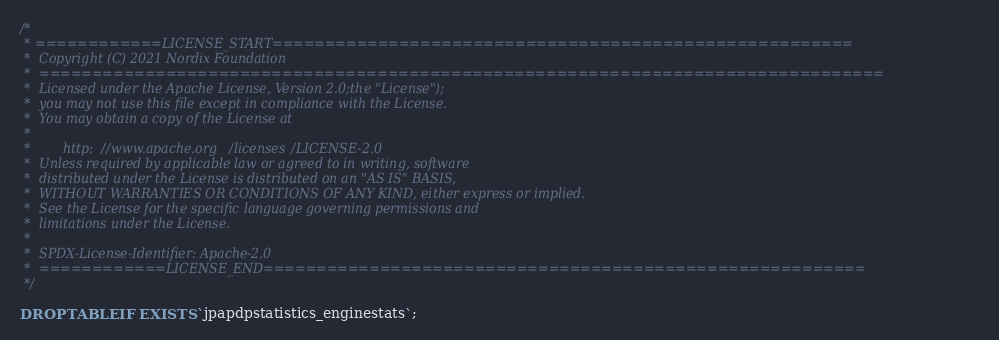Convert code to text. <code><loc_0><loc_0><loc_500><loc_500><_SQL_>/*
 * ============LICENSE_START=======================================================
 *  Copyright (C) 2021 Nordix Foundation
 *  ================================================================================
 *  Licensed under the Apache License, Version 2.0;the "License");
 *  you may not use this file except in compliance with the License.
 *  You may obtain a copy of the License at
 *
 *        http://www.apache.org/licenses/LICENSE-2.0
 *  Unless required by applicable law or agreed to in writing, software
 *  distributed under the License is distributed on an "AS IS" BASIS,
 *  WITHOUT WARRANTIES OR CONDITIONS OF ANY KIND, either express or implied.
 *  See the License for the specific language governing permissions and
 *  limitations under the License.
 *
 *  SPDX-License-Identifier: Apache-2.0
 *  ============LICENSE_END=========================================================
 */

DROP TABLE IF EXISTS `jpapdpstatistics_enginestats`;
</code> 